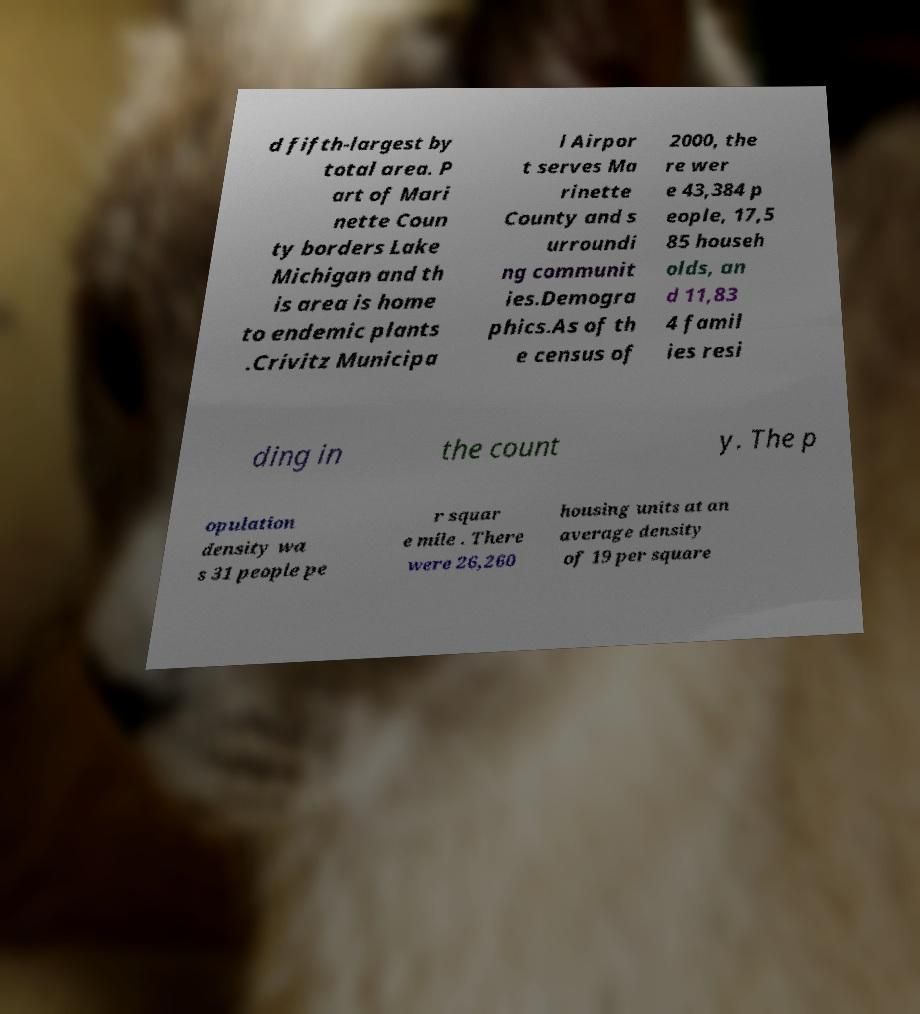There's text embedded in this image that I need extracted. Can you transcribe it verbatim? d fifth-largest by total area. P art of Mari nette Coun ty borders Lake Michigan and th is area is home to endemic plants .Crivitz Municipa l Airpor t serves Ma rinette County and s urroundi ng communit ies.Demogra phics.As of th e census of 2000, the re wer e 43,384 p eople, 17,5 85 househ olds, an d 11,83 4 famil ies resi ding in the count y. The p opulation density wa s 31 people pe r squar e mile . There were 26,260 housing units at an average density of 19 per square 